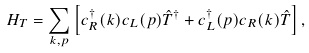Convert formula to latex. <formula><loc_0><loc_0><loc_500><loc_500>H _ { T } = \sum _ { k , p } \left [ c ^ { \dagger } _ { R } ( k ) c _ { L } ( p ) \hat { T } ^ { \dagger } + c ^ { \dagger } _ { L } ( p ) c _ { R } ( k ) \hat { T } \right ] ,</formula> 